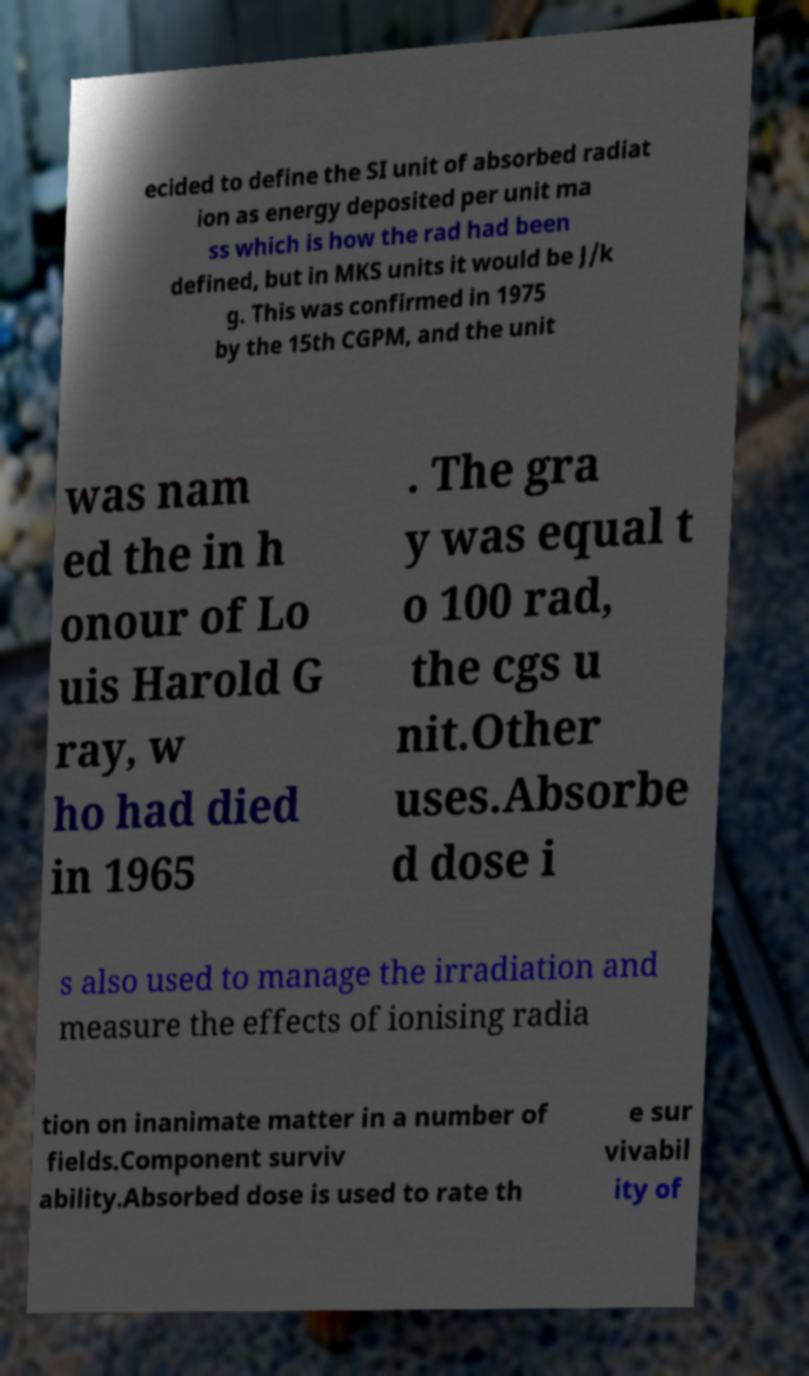Could you assist in decoding the text presented in this image and type it out clearly? ecided to define the SI unit of absorbed radiat ion as energy deposited per unit ma ss which is how the rad had been defined, but in MKS units it would be J/k g. This was confirmed in 1975 by the 15th CGPM, and the unit was nam ed the in h onour of Lo uis Harold G ray, w ho had died in 1965 . The gra y was equal t o 100 rad, the cgs u nit.Other uses.Absorbe d dose i s also used to manage the irradiation and measure the effects of ionising radia tion on inanimate matter in a number of fields.Component surviv ability.Absorbed dose is used to rate th e sur vivabil ity of 